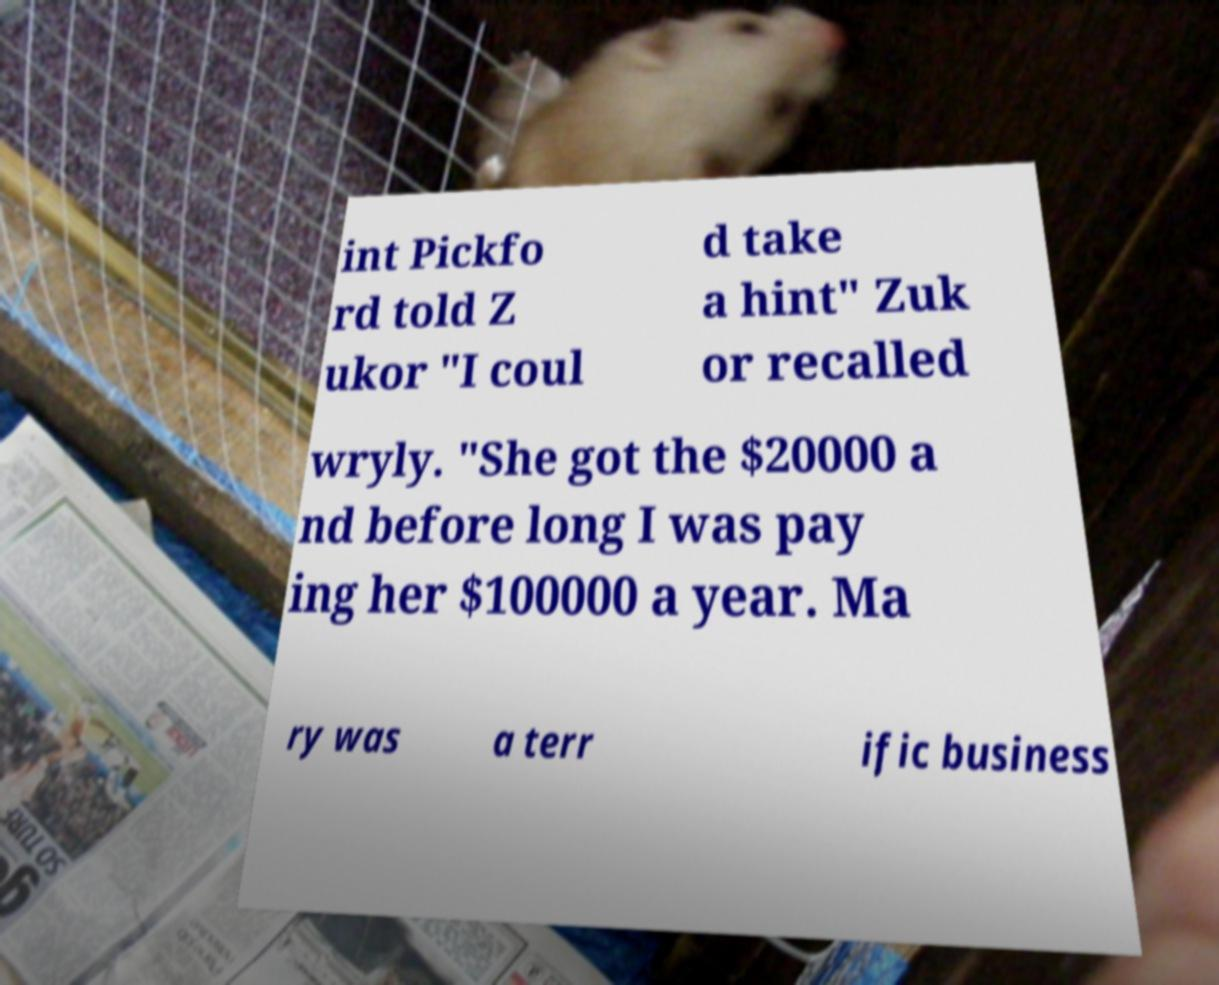Can you read and provide the text displayed in the image?This photo seems to have some interesting text. Can you extract and type it out for me? int Pickfo rd told Z ukor "I coul d take a hint" Zuk or recalled wryly. "She got the $20000 a nd before long I was pay ing her $100000 a year. Ma ry was a terr ific business 